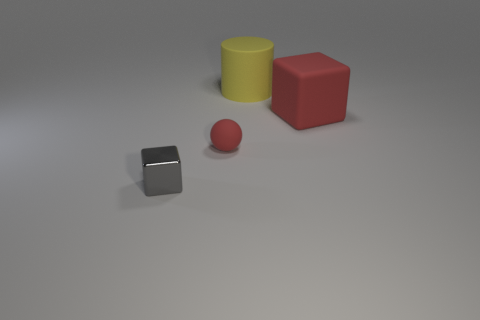Add 1 gray rubber cylinders. How many objects exist? 5 Subtract 0 green cylinders. How many objects are left? 4 Subtract all cylinders. How many objects are left? 3 Subtract 1 cylinders. How many cylinders are left? 0 Subtract all purple balls. Subtract all green cylinders. How many balls are left? 1 Subtract all yellow cylinders. How many red blocks are left? 1 Subtract all tiny cyan rubber balls. Subtract all red blocks. How many objects are left? 3 Add 3 red matte cubes. How many red matte cubes are left? 4 Add 1 large rubber cylinders. How many large rubber cylinders exist? 2 